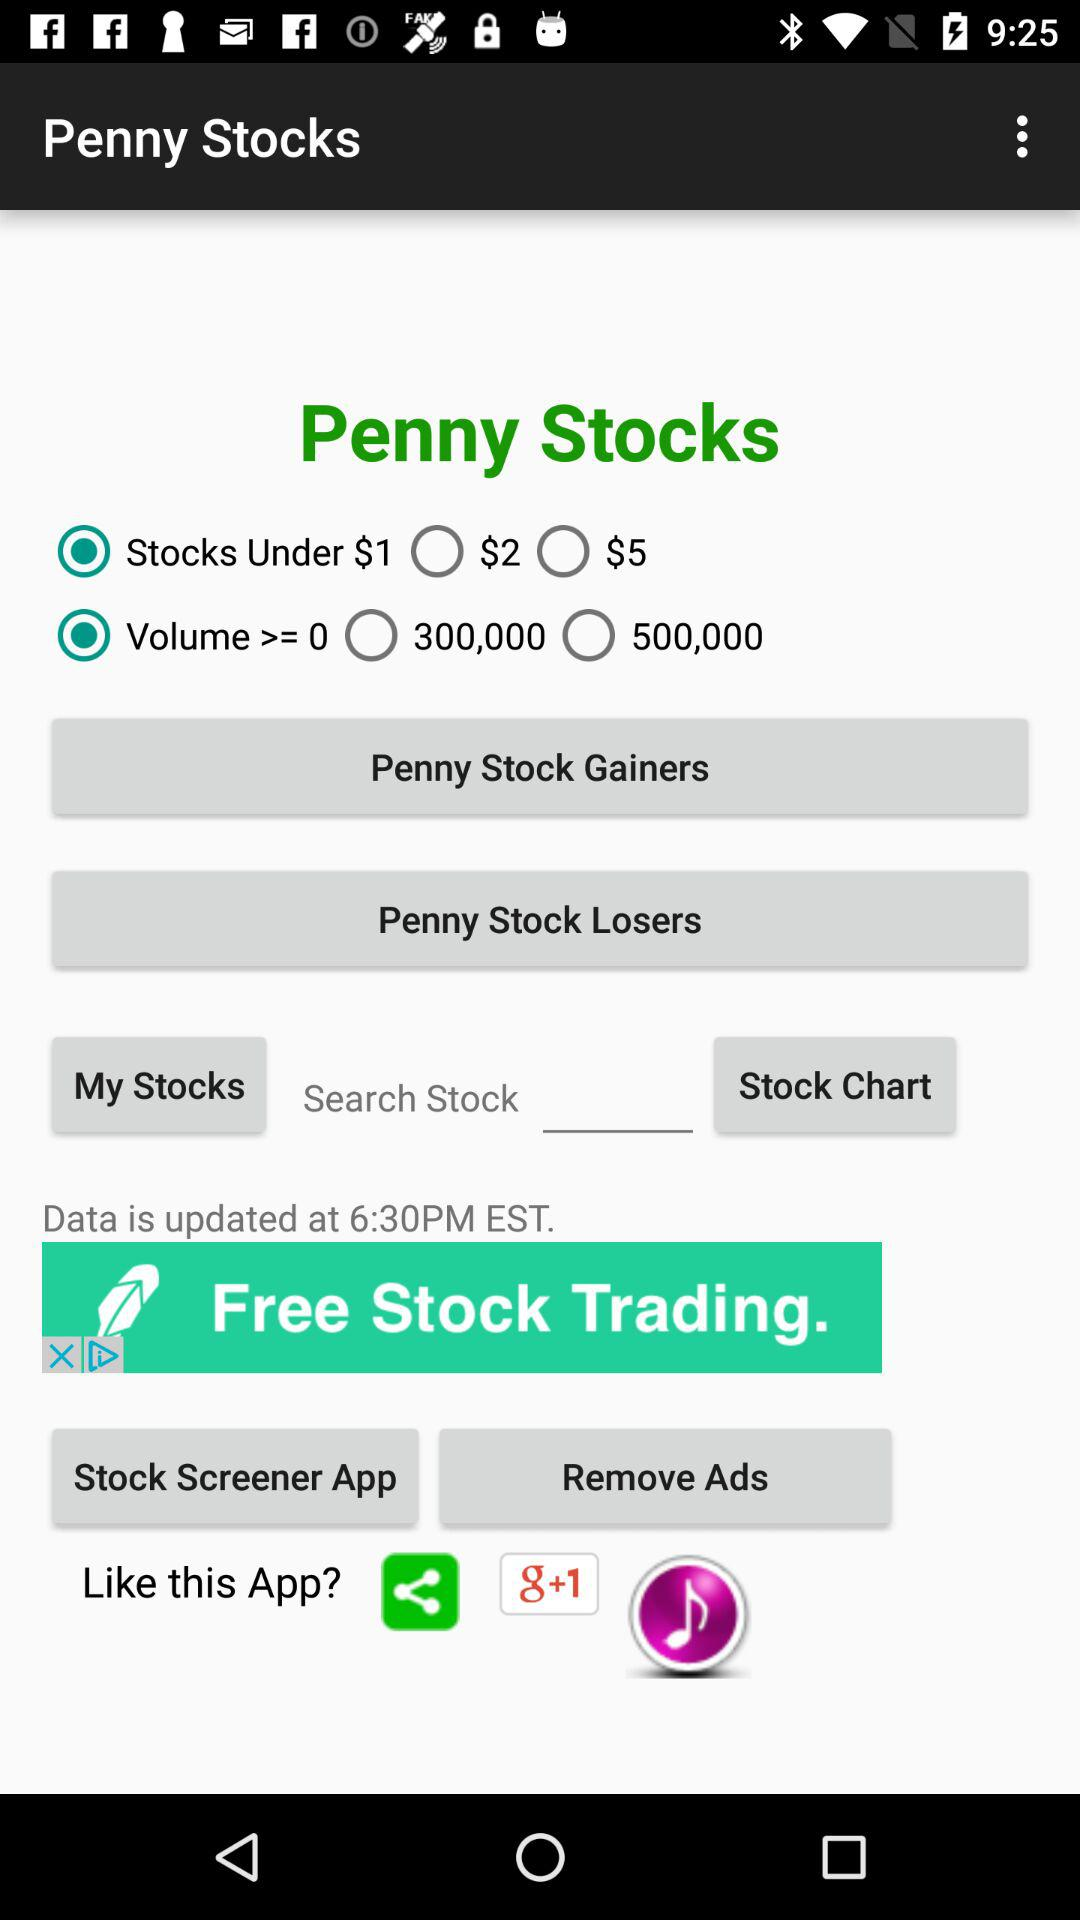Is "Stocks Under $1" selected or not? "Stocks Under $1" is selected. 